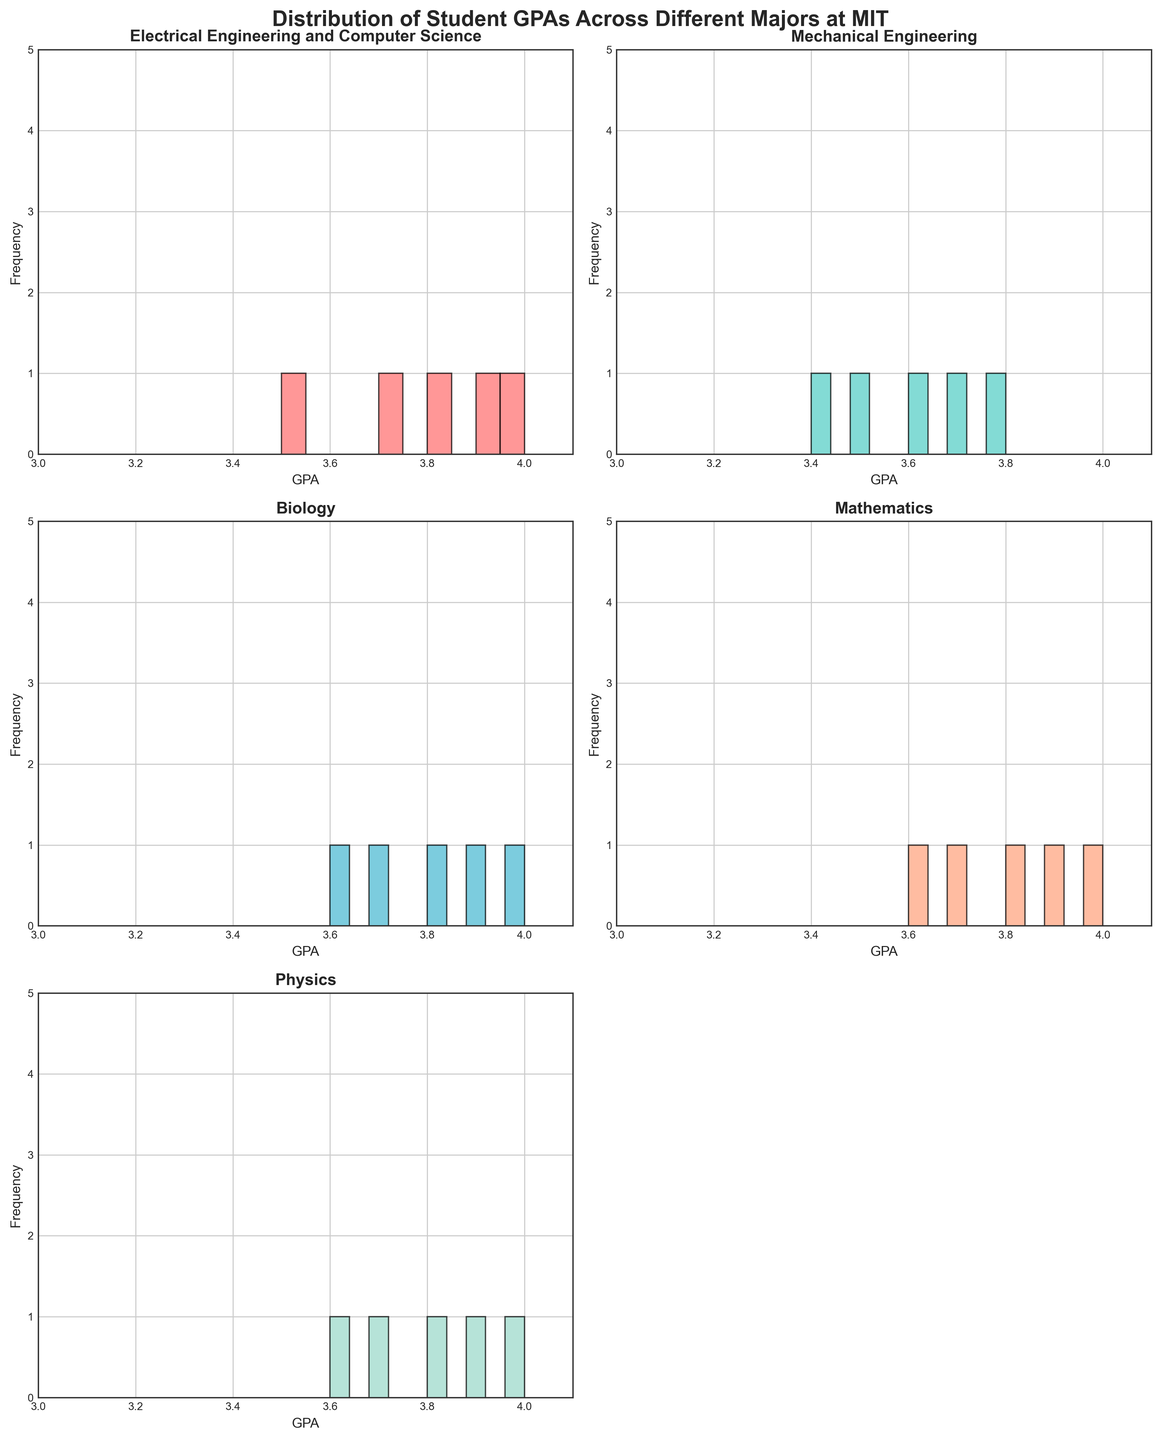What's the title of the figure? The title of the figure is written at the top and it summarizes what the figure is about. The title is "Distribution of Student GPAs Across Different Majors at MIT".
Answer: Distribution of Student GPAs Across Different Majors at MIT How many subplots are shown in the figure? By observing the layout of the figure, you can see that there are three rows and two columns of subplots. However, the last subplot on the third row is removed, so there are a total of 5 subplots.
Answer: 5 Which major has the highest individual GPA value? Looking at each subplot, the highest individual GPA value is 4.0. Check each subplot to see which majors have this value. Electrical Engineering and Computer Science, Biology, Mathematics, and Physics have this maximum value.
Answer: Electrical Engineering and Computer Science, Biology, Mathematics, and Physics Which major presents the least variability in GPA distribution? Less variability can be seen by looking at how tightly clustered the bars are in each histogram. Mathematics and Physics subplots appear to have GPAs tightly clustered around the 3.7-4.0 range.
Answer: Mathematics and Physics What is the common GPA range across all majors shown? By examining the x-axis of each histogram, the range of GPA values across all subplots spans from 3.4 to 4.0.
Answer: 3.4 to 4.0 Which major has the widest spread in their GPA distribution? The widest spread would be indicated by a histogram that has bars (frequencies) across a broader range of GPA values. Mechanical Engineering shows bars from 3.4 to 3.8 while others are more concentrated around particular values.
Answer: Mechanical Engineering How many students major in Electrical Engineering and Computer Science? Count the number of bars in the Electrical Engineering and Computer Science histogram. Each bar represents a data point and we can see there are 5 bars present in this histogram.
Answer: 5 Are there any majors where all students have a GPA above 3.5? Look at the histograms and check the range of GPA values in each subplot. All majors have their GPAs above 3.5 except Mechanical Engineering which has a GPA of 3.4.
Answer: Yes, except Mechanical Engineering Which major has the highest frequency of a perfect 4.0 GPA? Find the bars representing GPAs of 4.0 in each subplot. Count the frequency within each subplot. Electrical Engineering and Computer Science, Biology, Mathematics, and Physics each have one student with a perfect GPA.
Answer: Tied between Electrical Engineering and Computer Science, Biology, Mathematics, and Physics Which major seems to have the highest average GPA among its students? To find this, notice how the bars are distributed. The subplots with bars shifted more towards the right (4.0) will likely have a higher average. Biology and Mathematics appear to have GPAs mostly around 3.8 to 4.0.
Answer: Biology and Mathematics 